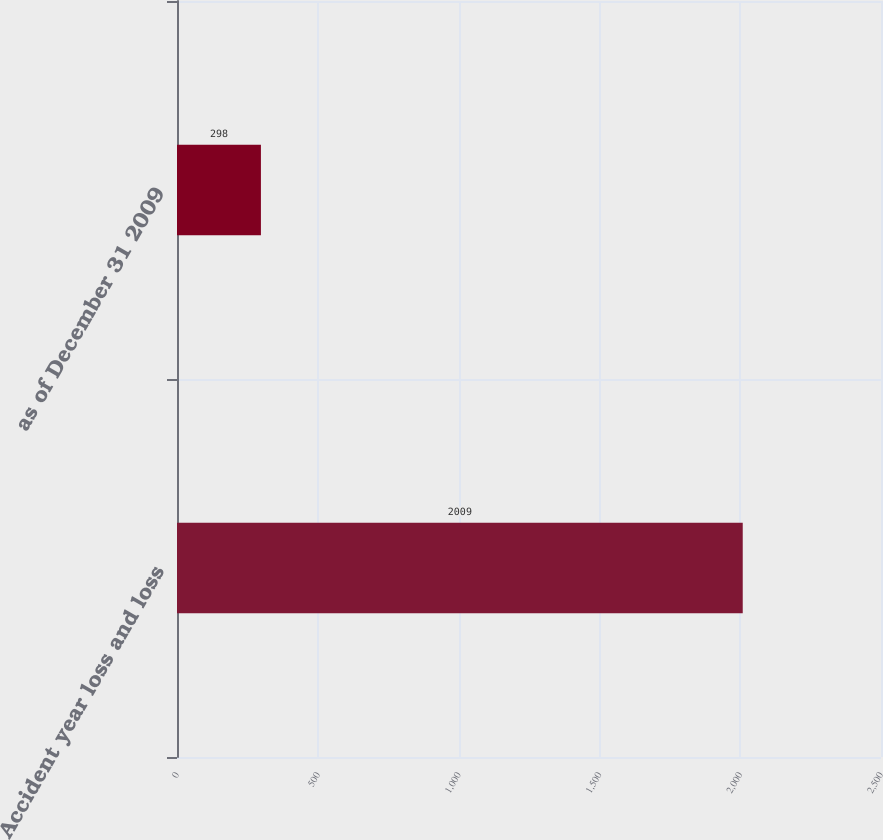Convert chart. <chart><loc_0><loc_0><loc_500><loc_500><bar_chart><fcel>Accident year loss and loss<fcel>as of December 31 2009<nl><fcel>2009<fcel>298<nl></chart> 